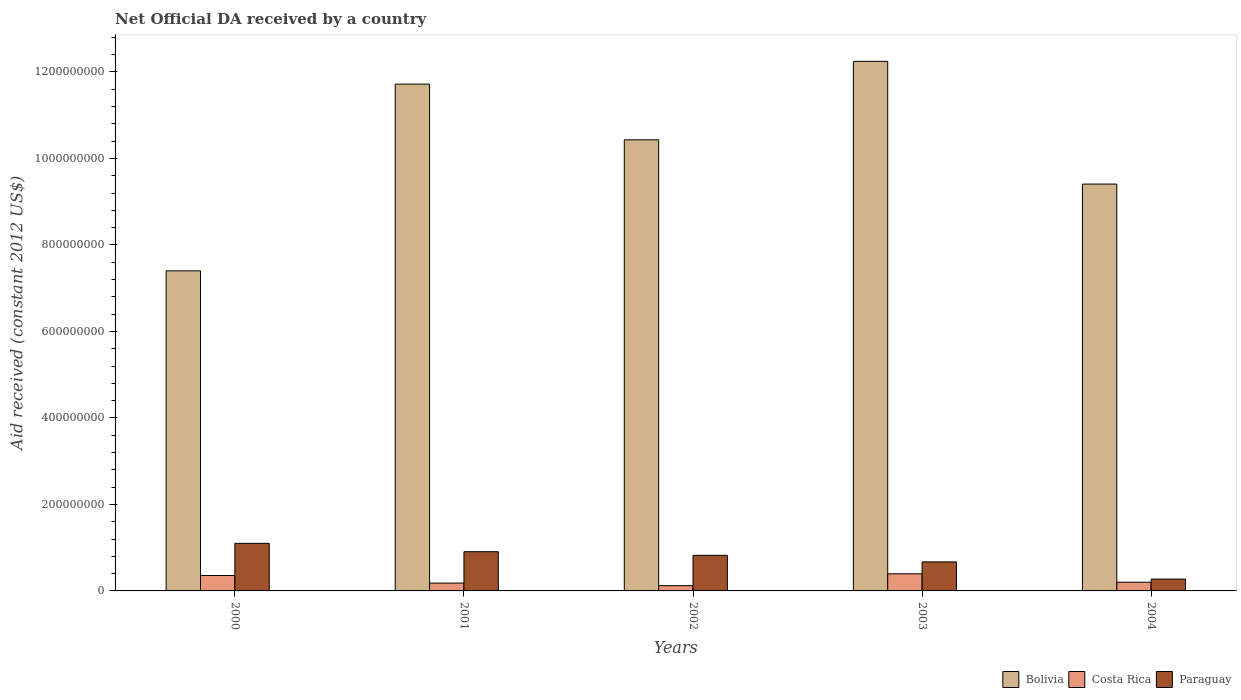How many different coloured bars are there?
Keep it short and to the point. 3. Are the number of bars per tick equal to the number of legend labels?
Make the answer very short. Yes. How many bars are there on the 2nd tick from the left?
Your answer should be compact. 3. In how many cases, is the number of bars for a given year not equal to the number of legend labels?
Offer a terse response. 0. What is the net official development assistance aid received in Paraguay in 2000?
Offer a very short reply. 1.10e+08. Across all years, what is the maximum net official development assistance aid received in Bolivia?
Offer a terse response. 1.22e+09. Across all years, what is the minimum net official development assistance aid received in Bolivia?
Give a very brief answer. 7.40e+08. In which year was the net official development assistance aid received in Paraguay minimum?
Your answer should be compact. 2004. What is the total net official development assistance aid received in Costa Rica in the graph?
Provide a succinct answer. 1.26e+08. What is the difference between the net official development assistance aid received in Paraguay in 2000 and that in 2003?
Your response must be concise. 4.29e+07. What is the difference between the net official development assistance aid received in Costa Rica in 2000 and the net official development assistance aid received in Paraguay in 2003?
Provide a succinct answer. -3.14e+07. What is the average net official development assistance aid received in Costa Rica per year?
Provide a succinct answer. 2.51e+07. In the year 2001, what is the difference between the net official development assistance aid received in Bolivia and net official development assistance aid received in Paraguay?
Provide a short and direct response. 1.08e+09. In how many years, is the net official development assistance aid received in Paraguay greater than 800000000 US$?
Your response must be concise. 0. What is the ratio of the net official development assistance aid received in Paraguay in 2001 to that in 2004?
Your answer should be very brief. 3.32. Is the net official development assistance aid received in Costa Rica in 2000 less than that in 2004?
Give a very brief answer. No. What is the difference between the highest and the second highest net official development assistance aid received in Paraguay?
Give a very brief answer. 1.93e+07. What is the difference between the highest and the lowest net official development assistance aid received in Costa Rica?
Provide a succinct answer. 2.74e+07. Is the sum of the net official development assistance aid received in Costa Rica in 2003 and 2004 greater than the maximum net official development assistance aid received in Paraguay across all years?
Provide a short and direct response. No. What does the 2nd bar from the right in 2001 represents?
Offer a terse response. Costa Rica. Is it the case that in every year, the sum of the net official development assistance aid received in Costa Rica and net official development assistance aid received in Paraguay is greater than the net official development assistance aid received in Bolivia?
Ensure brevity in your answer.  No. How many bars are there?
Your response must be concise. 15. How many years are there in the graph?
Provide a succinct answer. 5. What is the difference between two consecutive major ticks on the Y-axis?
Give a very brief answer. 2.00e+08. Does the graph contain grids?
Your answer should be compact. No. What is the title of the graph?
Offer a very short reply. Net Official DA received by a country. Does "Monaco" appear as one of the legend labels in the graph?
Keep it short and to the point. No. What is the label or title of the X-axis?
Offer a terse response. Years. What is the label or title of the Y-axis?
Make the answer very short. Aid received (constant 2012 US$). What is the Aid received (constant 2012 US$) of Bolivia in 2000?
Your response must be concise. 7.40e+08. What is the Aid received (constant 2012 US$) of Costa Rica in 2000?
Your answer should be compact. 3.57e+07. What is the Aid received (constant 2012 US$) of Paraguay in 2000?
Your answer should be very brief. 1.10e+08. What is the Aid received (constant 2012 US$) in Bolivia in 2001?
Offer a very short reply. 1.17e+09. What is the Aid received (constant 2012 US$) in Costa Rica in 2001?
Your answer should be compact. 1.81e+07. What is the Aid received (constant 2012 US$) in Paraguay in 2001?
Give a very brief answer. 9.07e+07. What is the Aid received (constant 2012 US$) of Bolivia in 2002?
Provide a succinct answer. 1.04e+09. What is the Aid received (constant 2012 US$) of Costa Rica in 2002?
Keep it short and to the point. 1.22e+07. What is the Aid received (constant 2012 US$) in Paraguay in 2002?
Your answer should be very brief. 8.23e+07. What is the Aid received (constant 2012 US$) of Bolivia in 2003?
Offer a terse response. 1.22e+09. What is the Aid received (constant 2012 US$) of Costa Rica in 2003?
Offer a terse response. 3.96e+07. What is the Aid received (constant 2012 US$) of Paraguay in 2003?
Ensure brevity in your answer.  6.71e+07. What is the Aid received (constant 2012 US$) in Bolivia in 2004?
Your answer should be compact. 9.41e+08. What is the Aid received (constant 2012 US$) of Costa Rica in 2004?
Keep it short and to the point. 2.01e+07. What is the Aid received (constant 2012 US$) of Paraguay in 2004?
Ensure brevity in your answer.  2.73e+07. Across all years, what is the maximum Aid received (constant 2012 US$) in Bolivia?
Ensure brevity in your answer.  1.22e+09. Across all years, what is the maximum Aid received (constant 2012 US$) of Costa Rica?
Make the answer very short. 3.96e+07. Across all years, what is the maximum Aid received (constant 2012 US$) of Paraguay?
Your answer should be compact. 1.10e+08. Across all years, what is the minimum Aid received (constant 2012 US$) of Bolivia?
Your answer should be compact. 7.40e+08. Across all years, what is the minimum Aid received (constant 2012 US$) of Costa Rica?
Give a very brief answer. 1.22e+07. Across all years, what is the minimum Aid received (constant 2012 US$) in Paraguay?
Offer a terse response. 2.73e+07. What is the total Aid received (constant 2012 US$) in Bolivia in the graph?
Provide a succinct answer. 5.12e+09. What is the total Aid received (constant 2012 US$) in Costa Rica in the graph?
Keep it short and to the point. 1.26e+08. What is the total Aid received (constant 2012 US$) in Paraguay in the graph?
Offer a terse response. 3.77e+08. What is the difference between the Aid received (constant 2012 US$) of Bolivia in 2000 and that in 2001?
Your answer should be compact. -4.32e+08. What is the difference between the Aid received (constant 2012 US$) of Costa Rica in 2000 and that in 2001?
Ensure brevity in your answer.  1.76e+07. What is the difference between the Aid received (constant 2012 US$) in Paraguay in 2000 and that in 2001?
Provide a succinct answer. 1.93e+07. What is the difference between the Aid received (constant 2012 US$) of Bolivia in 2000 and that in 2002?
Ensure brevity in your answer.  -3.03e+08. What is the difference between the Aid received (constant 2012 US$) of Costa Rica in 2000 and that in 2002?
Your response must be concise. 2.35e+07. What is the difference between the Aid received (constant 2012 US$) of Paraguay in 2000 and that in 2002?
Provide a succinct answer. 2.77e+07. What is the difference between the Aid received (constant 2012 US$) in Bolivia in 2000 and that in 2003?
Ensure brevity in your answer.  -4.84e+08. What is the difference between the Aid received (constant 2012 US$) in Costa Rica in 2000 and that in 2003?
Make the answer very short. -3.89e+06. What is the difference between the Aid received (constant 2012 US$) in Paraguay in 2000 and that in 2003?
Provide a short and direct response. 4.29e+07. What is the difference between the Aid received (constant 2012 US$) of Bolivia in 2000 and that in 2004?
Keep it short and to the point. -2.01e+08. What is the difference between the Aid received (constant 2012 US$) of Costa Rica in 2000 and that in 2004?
Make the answer very short. 1.56e+07. What is the difference between the Aid received (constant 2012 US$) of Paraguay in 2000 and that in 2004?
Your answer should be compact. 8.27e+07. What is the difference between the Aid received (constant 2012 US$) in Bolivia in 2001 and that in 2002?
Provide a succinct answer. 1.29e+08. What is the difference between the Aid received (constant 2012 US$) of Costa Rica in 2001 and that in 2002?
Make the answer very short. 5.91e+06. What is the difference between the Aid received (constant 2012 US$) of Paraguay in 2001 and that in 2002?
Give a very brief answer. 8.41e+06. What is the difference between the Aid received (constant 2012 US$) in Bolivia in 2001 and that in 2003?
Ensure brevity in your answer.  -5.26e+07. What is the difference between the Aid received (constant 2012 US$) of Costa Rica in 2001 and that in 2003?
Provide a succinct answer. -2.15e+07. What is the difference between the Aid received (constant 2012 US$) of Paraguay in 2001 and that in 2003?
Offer a terse response. 2.36e+07. What is the difference between the Aid received (constant 2012 US$) of Bolivia in 2001 and that in 2004?
Keep it short and to the point. 2.31e+08. What is the difference between the Aid received (constant 2012 US$) of Costa Rica in 2001 and that in 2004?
Provide a short and direct response. -2.03e+06. What is the difference between the Aid received (constant 2012 US$) of Paraguay in 2001 and that in 2004?
Make the answer very short. 6.34e+07. What is the difference between the Aid received (constant 2012 US$) in Bolivia in 2002 and that in 2003?
Give a very brief answer. -1.81e+08. What is the difference between the Aid received (constant 2012 US$) of Costa Rica in 2002 and that in 2003?
Make the answer very short. -2.74e+07. What is the difference between the Aid received (constant 2012 US$) in Paraguay in 2002 and that in 2003?
Give a very brief answer. 1.52e+07. What is the difference between the Aid received (constant 2012 US$) of Bolivia in 2002 and that in 2004?
Keep it short and to the point. 1.02e+08. What is the difference between the Aid received (constant 2012 US$) in Costa Rica in 2002 and that in 2004?
Your response must be concise. -7.94e+06. What is the difference between the Aid received (constant 2012 US$) of Paraguay in 2002 and that in 2004?
Your response must be concise. 5.50e+07. What is the difference between the Aid received (constant 2012 US$) of Bolivia in 2003 and that in 2004?
Offer a terse response. 2.84e+08. What is the difference between the Aid received (constant 2012 US$) of Costa Rica in 2003 and that in 2004?
Your response must be concise. 1.94e+07. What is the difference between the Aid received (constant 2012 US$) of Paraguay in 2003 and that in 2004?
Keep it short and to the point. 3.98e+07. What is the difference between the Aid received (constant 2012 US$) in Bolivia in 2000 and the Aid received (constant 2012 US$) in Costa Rica in 2001?
Offer a very short reply. 7.22e+08. What is the difference between the Aid received (constant 2012 US$) in Bolivia in 2000 and the Aid received (constant 2012 US$) in Paraguay in 2001?
Your answer should be very brief. 6.49e+08. What is the difference between the Aid received (constant 2012 US$) in Costa Rica in 2000 and the Aid received (constant 2012 US$) in Paraguay in 2001?
Keep it short and to the point. -5.50e+07. What is the difference between the Aid received (constant 2012 US$) in Bolivia in 2000 and the Aid received (constant 2012 US$) in Costa Rica in 2002?
Your answer should be compact. 7.28e+08. What is the difference between the Aid received (constant 2012 US$) of Bolivia in 2000 and the Aid received (constant 2012 US$) of Paraguay in 2002?
Provide a short and direct response. 6.58e+08. What is the difference between the Aid received (constant 2012 US$) in Costa Rica in 2000 and the Aid received (constant 2012 US$) in Paraguay in 2002?
Your answer should be compact. -4.66e+07. What is the difference between the Aid received (constant 2012 US$) in Bolivia in 2000 and the Aid received (constant 2012 US$) in Costa Rica in 2003?
Keep it short and to the point. 7.01e+08. What is the difference between the Aid received (constant 2012 US$) of Bolivia in 2000 and the Aid received (constant 2012 US$) of Paraguay in 2003?
Give a very brief answer. 6.73e+08. What is the difference between the Aid received (constant 2012 US$) in Costa Rica in 2000 and the Aid received (constant 2012 US$) in Paraguay in 2003?
Provide a succinct answer. -3.14e+07. What is the difference between the Aid received (constant 2012 US$) in Bolivia in 2000 and the Aid received (constant 2012 US$) in Costa Rica in 2004?
Provide a succinct answer. 7.20e+08. What is the difference between the Aid received (constant 2012 US$) of Bolivia in 2000 and the Aid received (constant 2012 US$) of Paraguay in 2004?
Offer a terse response. 7.13e+08. What is the difference between the Aid received (constant 2012 US$) of Costa Rica in 2000 and the Aid received (constant 2012 US$) of Paraguay in 2004?
Your answer should be compact. 8.35e+06. What is the difference between the Aid received (constant 2012 US$) in Bolivia in 2001 and the Aid received (constant 2012 US$) in Costa Rica in 2002?
Give a very brief answer. 1.16e+09. What is the difference between the Aid received (constant 2012 US$) of Bolivia in 2001 and the Aid received (constant 2012 US$) of Paraguay in 2002?
Make the answer very short. 1.09e+09. What is the difference between the Aid received (constant 2012 US$) of Costa Rica in 2001 and the Aid received (constant 2012 US$) of Paraguay in 2002?
Your response must be concise. -6.42e+07. What is the difference between the Aid received (constant 2012 US$) in Bolivia in 2001 and the Aid received (constant 2012 US$) in Costa Rica in 2003?
Your answer should be compact. 1.13e+09. What is the difference between the Aid received (constant 2012 US$) of Bolivia in 2001 and the Aid received (constant 2012 US$) of Paraguay in 2003?
Keep it short and to the point. 1.10e+09. What is the difference between the Aid received (constant 2012 US$) in Costa Rica in 2001 and the Aid received (constant 2012 US$) in Paraguay in 2003?
Offer a terse response. -4.90e+07. What is the difference between the Aid received (constant 2012 US$) in Bolivia in 2001 and the Aid received (constant 2012 US$) in Costa Rica in 2004?
Give a very brief answer. 1.15e+09. What is the difference between the Aid received (constant 2012 US$) of Bolivia in 2001 and the Aid received (constant 2012 US$) of Paraguay in 2004?
Offer a very short reply. 1.14e+09. What is the difference between the Aid received (constant 2012 US$) in Costa Rica in 2001 and the Aid received (constant 2012 US$) in Paraguay in 2004?
Offer a terse response. -9.23e+06. What is the difference between the Aid received (constant 2012 US$) in Bolivia in 2002 and the Aid received (constant 2012 US$) in Costa Rica in 2003?
Your response must be concise. 1.00e+09. What is the difference between the Aid received (constant 2012 US$) of Bolivia in 2002 and the Aid received (constant 2012 US$) of Paraguay in 2003?
Offer a terse response. 9.76e+08. What is the difference between the Aid received (constant 2012 US$) of Costa Rica in 2002 and the Aid received (constant 2012 US$) of Paraguay in 2003?
Ensure brevity in your answer.  -5.49e+07. What is the difference between the Aid received (constant 2012 US$) of Bolivia in 2002 and the Aid received (constant 2012 US$) of Costa Rica in 2004?
Ensure brevity in your answer.  1.02e+09. What is the difference between the Aid received (constant 2012 US$) of Bolivia in 2002 and the Aid received (constant 2012 US$) of Paraguay in 2004?
Your answer should be very brief. 1.02e+09. What is the difference between the Aid received (constant 2012 US$) in Costa Rica in 2002 and the Aid received (constant 2012 US$) in Paraguay in 2004?
Your response must be concise. -1.51e+07. What is the difference between the Aid received (constant 2012 US$) in Bolivia in 2003 and the Aid received (constant 2012 US$) in Costa Rica in 2004?
Provide a short and direct response. 1.20e+09. What is the difference between the Aid received (constant 2012 US$) of Bolivia in 2003 and the Aid received (constant 2012 US$) of Paraguay in 2004?
Keep it short and to the point. 1.20e+09. What is the difference between the Aid received (constant 2012 US$) of Costa Rica in 2003 and the Aid received (constant 2012 US$) of Paraguay in 2004?
Give a very brief answer. 1.22e+07. What is the average Aid received (constant 2012 US$) in Bolivia per year?
Your response must be concise. 1.02e+09. What is the average Aid received (constant 2012 US$) of Costa Rica per year?
Offer a very short reply. 2.51e+07. What is the average Aid received (constant 2012 US$) in Paraguay per year?
Ensure brevity in your answer.  7.55e+07. In the year 2000, what is the difference between the Aid received (constant 2012 US$) in Bolivia and Aid received (constant 2012 US$) in Costa Rica?
Make the answer very short. 7.04e+08. In the year 2000, what is the difference between the Aid received (constant 2012 US$) in Bolivia and Aid received (constant 2012 US$) in Paraguay?
Ensure brevity in your answer.  6.30e+08. In the year 2000, what is the difference between the Aid received (constant 2012 US$) of Costa Rica and Aid received (constant 2012 US$) of Paraguay?
Ensure brevity in your answer.  -7.43e+07. In the year 2001, what is the difference between the Aid received (constant 2012 US$) in Bolivia and Aid received (constant 2012 US$) in Costa Rica?
Provide a short and direct response. 1.15e+09. In the year 2001, what is the difference between the Aid received (constant 2012 US$) of Bolivia and Aid received (constant 2012 US$) of Paraguay?
Offer a terse response. 1.08e+09. In the year 2001, what is the difference between the Aid received (constant 2012 US$) of Costa Rica and Aid received (constant 2012 US$) of Paraguay?
Provide a short and direct response. -7.26e+07. In the year 2002, what is the difference between the Aid received (constant 2012 US$) in Bolivia and Aid received (constant 2012 US$) in Costa Rica?
Keep it short and to the point. 1.03e+09. In the year 2002, what is the difference between the Aid received (constant 2012 US$) of Bolivia and Aid received (constant 2012 US$) of Paraguay?
Make the answer very short. 9.61e+08. In the year 2002, what is the difference between the Aid received (constant 2012 US$) in Costa Rica and Aid received (constant 2012 US$) in Paraguay?
Your answer should be very brief. -7.01e+07. In the year 2003, what is the difference between the Aid received (constant 2012 US$) in Bolivia and Aid received (constant 2012 US$) in Costa Rica?
Provide a short and direct response. 1.18e+09. In the year 2003, what is the difference between the Aid received (constant 2012 US$) in Bolivia and Aid received (constant 2012 US$) in Paraguay?
Your answer should be very brief. 1.16e+09. In the year 2003, what is the difference between the Aid received (constant 2012 US$) of Costa Rica and Aid received (constant 2012 US$) of Paraguay?
Offer a very short reply. -2.75e+07. In the year 2004, what is the difference between the Aid received (constant 2012 US$) in Bolivia and Aid received (constant 2012 US$) in Costa Rica?
Offer a terse response. 9.21e+08. In the year 2004, what is the difference between the Aid received (constant 2012 US$) of Bolivia and Aid received (constant 2012 US$) of Paraguay?
Ensure brevity in your answer.  9.13e+08. In the year 2004, what is the difference between the Aid received (constant 2012 US$) of Costa Rica and Aid received (constant 2012 US$) of Paraguay?
Provide a succinct answer. -7.20e+06. What is the ratio of the Aid received (constant 2012 US$) of Bolivia in 2000 to that in 2001?
Offer a terse response. 0.63. What is the ratio of the Aid received (constant 2012 US$) of Costa Rica in 2000 to that in 2001?
Your response must be concise. 1.97. What is the ratio of the Aid received (constant 2012 US$) of Paraguay in 2000 to that in 2001?
Provide a succinct answer. 1.21. What is the ratio of the Aid received (constant 2012 US$) in Bolivia in 2000 to that in 2002?
Keep it short and to the point. 0.71. What is the ratio of the Aid received (constant 2012 US$) of Costa Rica in 2000 to that in 2002?
Ensure brevity in your answer.  2.93. What is the ratio of the Aid received (constant 2012 US$) in Paraguay in 2000 to that in 2002?
Your answer should be very brief. 1.34. What is the ratio of the Aid received (constant 2012 US$) of Bolivia in 2000 to that in 2003?
Provide a short and direct response. 0.6. What is the ratio of the Aid received (constant 2012 US$) of Costa Rica in 2000 to that in 2003?
Offer a very short reply. 0.9. What is the ratio of the Aid received (constant 2012 US$) of Paraguay in 2000 to that in 2003?
Ensure brevity in your answer.  1.64. What is the ratio of the Aid received (constant 2012 US$) of Bolivia in 2000 to that in 2004?
Give a very brief answer. 0.79. What is the ratio of the Aid received (constant 2012 US$) of Costa Rica in 2000 to that in 2004?
Give a very brief answer. 1.77. What is the ratio of the Aid received (constant 2012 US$) in Paraguay in 2000 to that in 2004?
Give a very brief answer. 4.03. What is the ratio of the Aid received (constant 2012 US$) of Bolivia in 2001 to that in 2002?
Offer a terse response. 1.12. What is the ratio of the Aid received (constant 2012 US$) of Costa Rica in 2001 to that in 2002?
Your answer should be compact. 1.49. What is the ratio of the Aid received (constant 2012 US$) of Paraguay in 2001 to that in 2002?
Provide a succinct answer. 1.1. What is the ratio of the Aid received (constant 2012 US$) in Bolivia in 2001 to that in 2003?
Give a very brief answer. 0.96. What is the ratio of the Aid received (constant 2012 US$) in Costa Rica in 2001 to that in 2003?
Provide a succinct answer. 0.46. What is the ratio of the Aid received (constant 2012 US$) in Paraguay in 2001 to that in 2003?
Your answer should be very brief. 1.35. What is the ratio of the Aid received (constant 2012 US$) of Bolivia in 2001 to that in 2004?
Offer a terse response. 1.25. What is the ratio of the Aid received (constant 2012 US$) in Costa Rica in 2001 to that in 2004?
Offer a very short reply. 0.9. What is the ratio of the Aid received (constant 2012 US$) of Paraguay in 2001 to that in 2004?
Offer a very short reply. 3.32. What is the ratio of the Aid received (constant 2012 US$) in Bolivia in 2002 to that in 2003?
Make the answer very short. 0.85. What is the ratio of the Aid received (constant 2012 US$) in Costa Rica in 2002 to that in 2003?
Provide a succinct answer. 0.31. What is the ratio of the Aid received (constant 2012 US$) in Paraguay in 2002 to that in 2003?
Provide a short and direct response. 1.23. What is the ratio of the Aid received (constant 2012 US$) of Bolivia in 2002 to that in 2004?
Make the answer very short. 1.11. What is the ratio of the Aid received (constant 2012 US$) in Costa Rica in 2002 to that in 2004?
Offer a terse response. 0.61. What is the ratio of the Aid received (constant 2012 US$) in Paraguay in 2002 to that in 2004?
Keep it short and to the point. 3.01. What is the ratio of the Aid received (constant 2012 US$) in Bolivia in 2003 to that in 2004?
Your answer should be very brief. 1.3. What is the ratio of the Aid received (constant 2012 US$) of Costa Rica in 2003 to that in 2004?
Your answer should be very brief. 1.97. What is the ratio of the Aid received (constant 2012 US$) of Paraguay in 2003 to that in 2004?
Your response must be concise. 2.46. What is the difference between the highest and the second highest Aid received (constant 2012 US$) of Bolivia?
Your response must be concise. 5.26e+07. What is the difference between the highest and the second highest Aid received (constant 2012 US$) of Costa Rica?
Give a very brief answer. 3.89e+06. What is the difference between the highest and the second highest Aid received (constant 2012 US$) of Paraguay?
Give a very brief answer. 1.93e+07. What is the difference between the highest and the lowest Aid received (constant 2012 US$) in Bolivia?
Offer a very short reply. 4.84e+08. What is the difference between the highest and the lowest Aid received (constant 2012 US$) of Costa Rica?
Keep it short and to the point. 2.74e+07. What is the difference between the highest and the lowest Aid received (constant 2012 US$) of Paraguay?
Your response must be concise. 8.27e+07. 